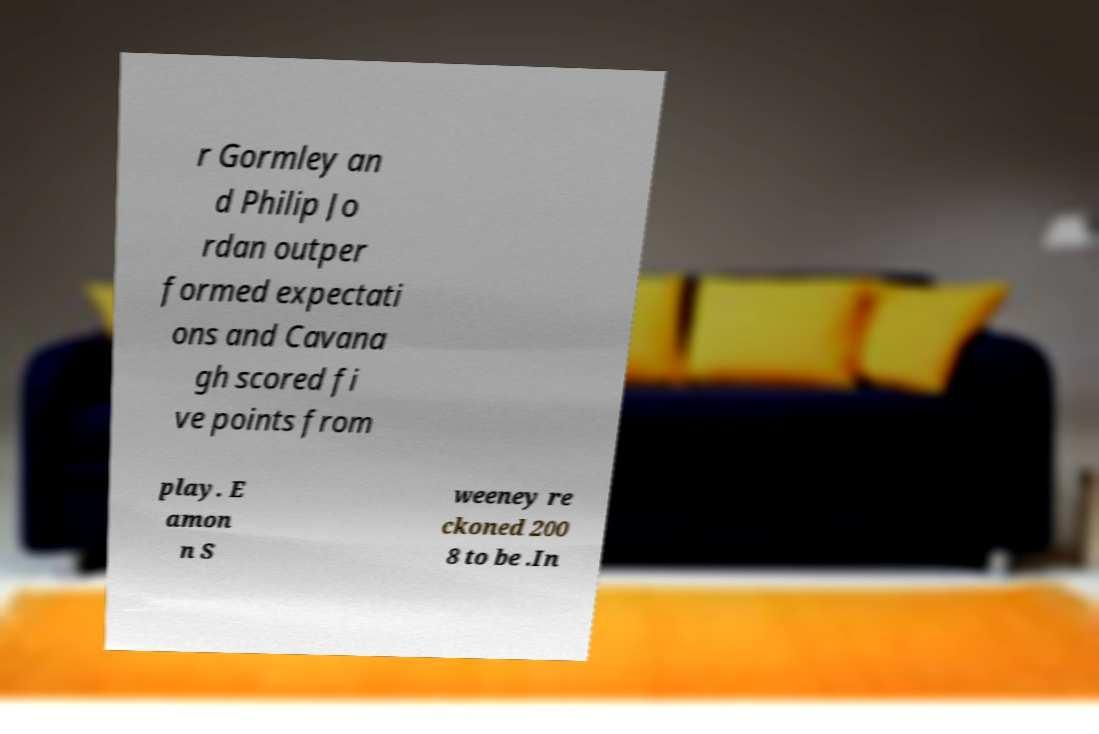Could you assist in decoding the text presented in this image and type it out clearly? r Gormley an d Philip Jo rdan outper formed expectati ons and Cavana gh scored fi ve points from play. E amon n S weeney re ckoned 200 8 to be .In 